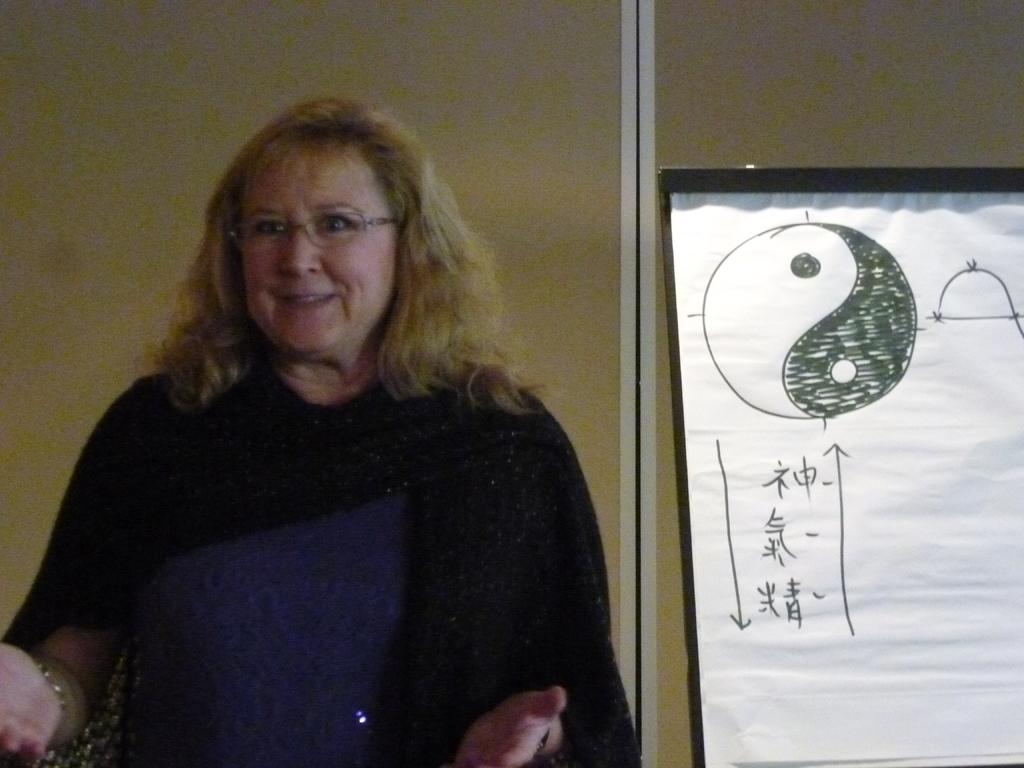Who is in the picture? There is a woman in the picture. What is the woman doing in the picture? The woman is standing and smiling. What can be seen on the right side of the picture? There is a board on the right side of the picture. What is visible in the background of the picture? There is a wall in the background of the picture. What type of print can be seen on the woman's shirt in the image? There is no information about the woman's shirt in the provided facts, so it is not possible to determine if there is a print on it. 